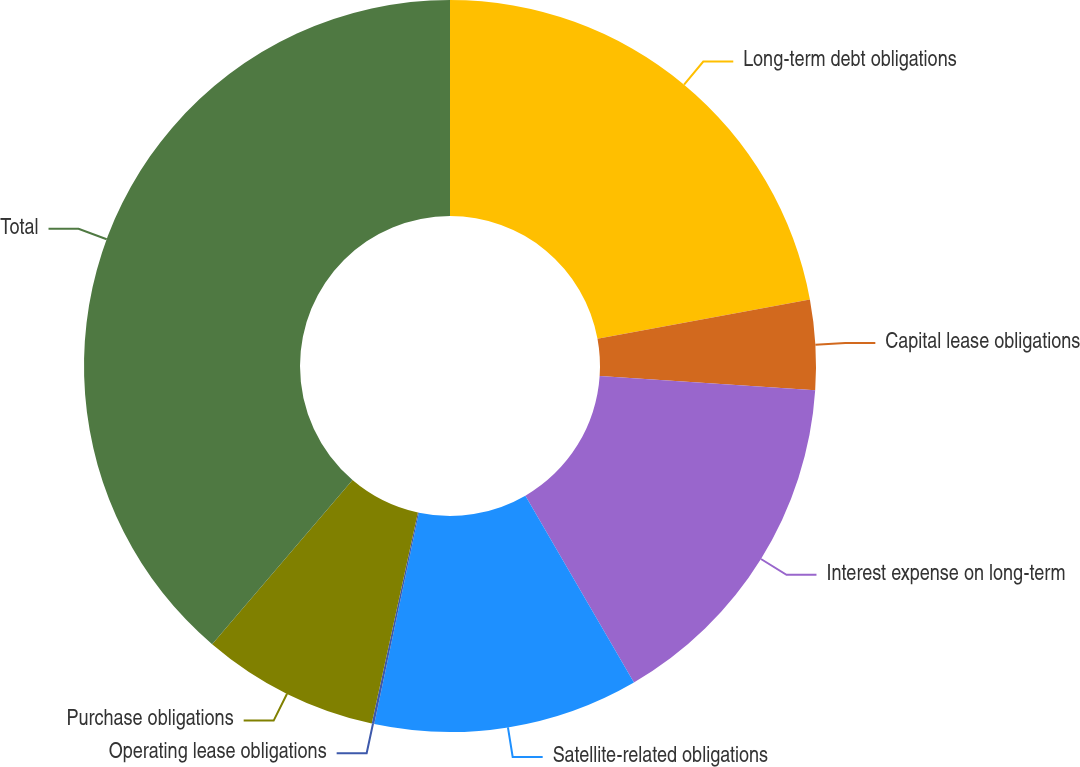<chart> <loc_0><loc_0><loc_500><loc_500><pie_chart><fcel>Long-term debt obligations<fcel>Capital lease obligations<fcel>Interest expense on long-term<fcel>Satellite-related obligations<fcel>Operating lease obligations<fcel>Purchase obligations<fcel>Total<nl><fcel>22.09%<fcel>3.97%<fcel>15.56%<fcel>11.7%<fcel>0.11%<fcel>7.83%<fcel>38.74%<nl></chart> 